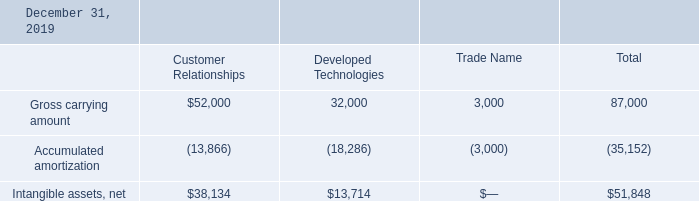Note 9. Intangible Assets, net
The Company’s definite-lived intangible assets as of December 31, 2019 and 2018 consisted of the following:
Amortization of definite-lived intangible assets is provided over their estimated useful lives on a straight-line basis or the pattern in which economic benefits are consumed, if reliably determinable. The Company reviews its definite-lived intangible assets for impairment whenever events or changes in circumstances indicate that the carrying amount of an asset may not be recoverable. Amortization expense from continuing and discontinued operations was $8,879 and $9,150 for the years ended December 31, 2019 and 2018, respectively
What are the respective values of the gross carrying amounts of Customer Relationships and Developed Technologies in 2019? 52,000, 32,000. What are the respective values of the accumulated amortization of Customer Relationships and Developed Technologies in 2019? 13,866, 18,286. What are the respective values of the net intangible assets of Customer Relationships and Developed Technologies in 2019? $38,134, $13,714. What is the average gross carrying amounts of Customer Relationships and Developed Technologies in 2019? (52,000 + 32,000)/2 
Answer: 42000. What is the average gross carrying amounts of Trade Name and Developed Technologies in 2019? (32,000 + 3,000)/2 
Answer: 17500. What is the value of the Trade Name as a percentage of the total gross carrying amount in 2019?
Answer scale should be: percent. 3,000/87,000 
Answer: 3.45. 